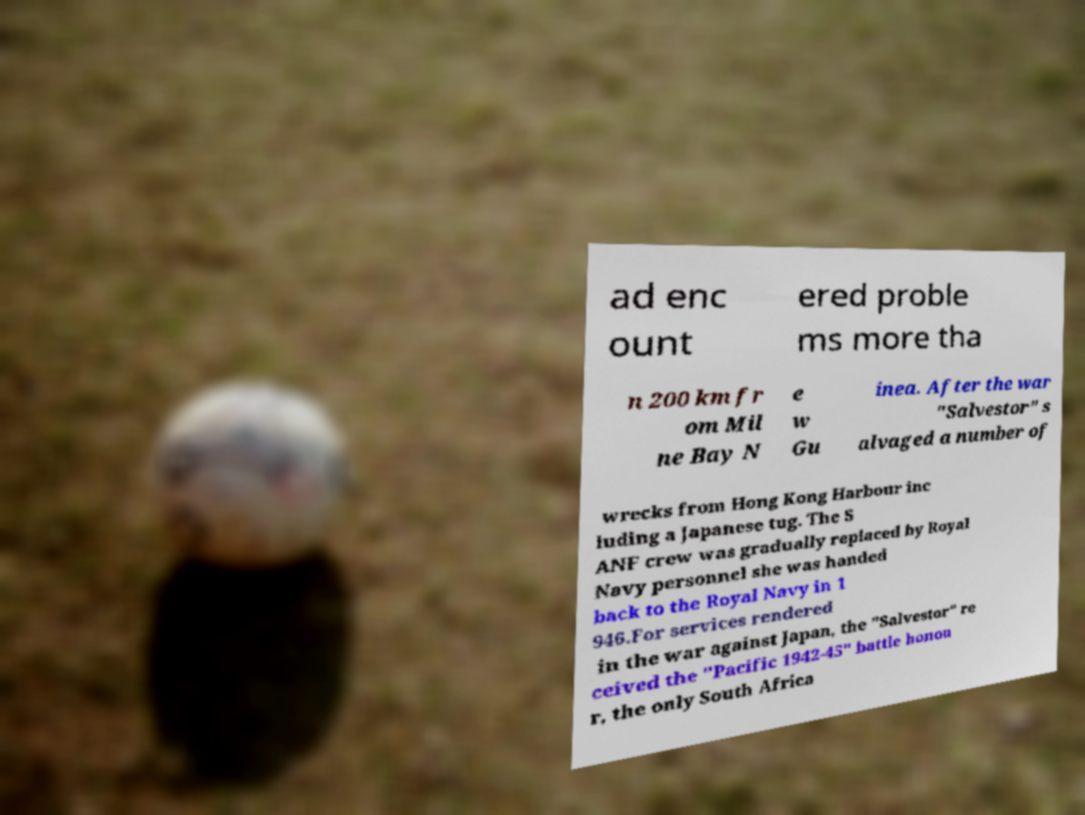For documentation purposes, I need the text within this image transcribed. Could you provide that? ad enc ount ered proble ms more tha n 200 km fr om Mil ne Bay N e w Gu inea. After the war "Salvestor" s alvaged a number of wrecks from Hong Kong Harbour inc luding a Japanese tug. The S ANF crew was gradually replaced by Royal Navy personnel she was handed back to the Royal Navy in 1 946.For services rendered in the war against Japan, the "Salvestor" re ceived the "Pacific 1942-45" battle honou r, the only South Africa 